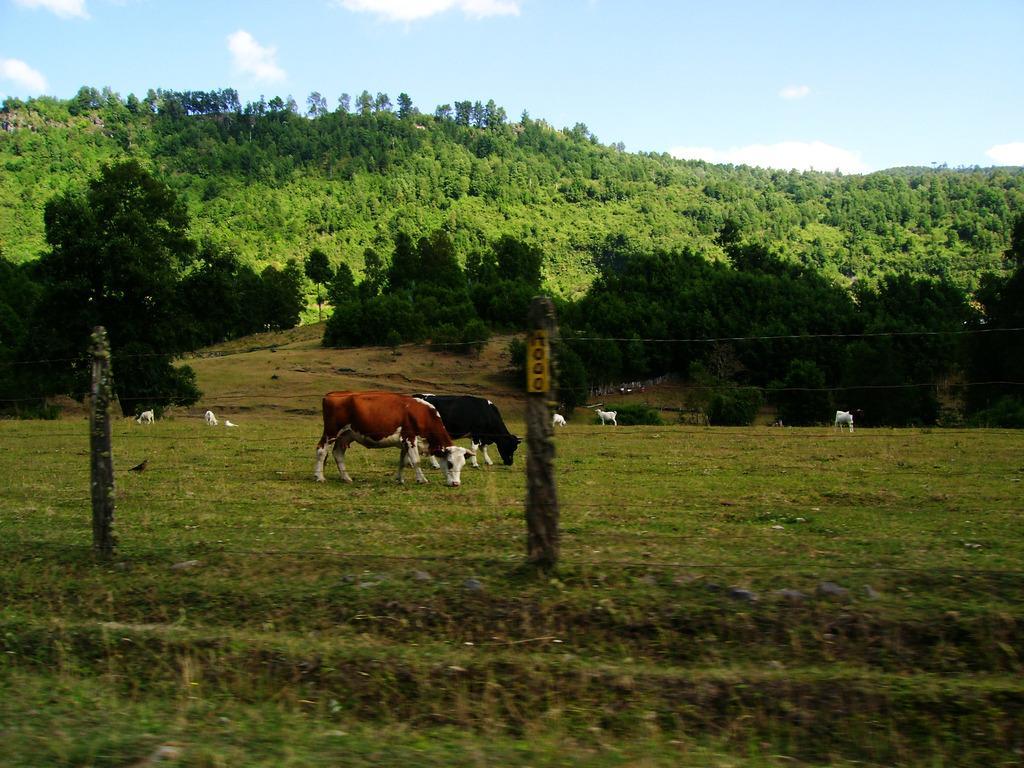Please provide a concise description of this image. In this image I can see an open grass ground, few poles, wires, few cows, few other animals and number of trees. I can also see clouds and the sky in background. Here I can see something is written. 